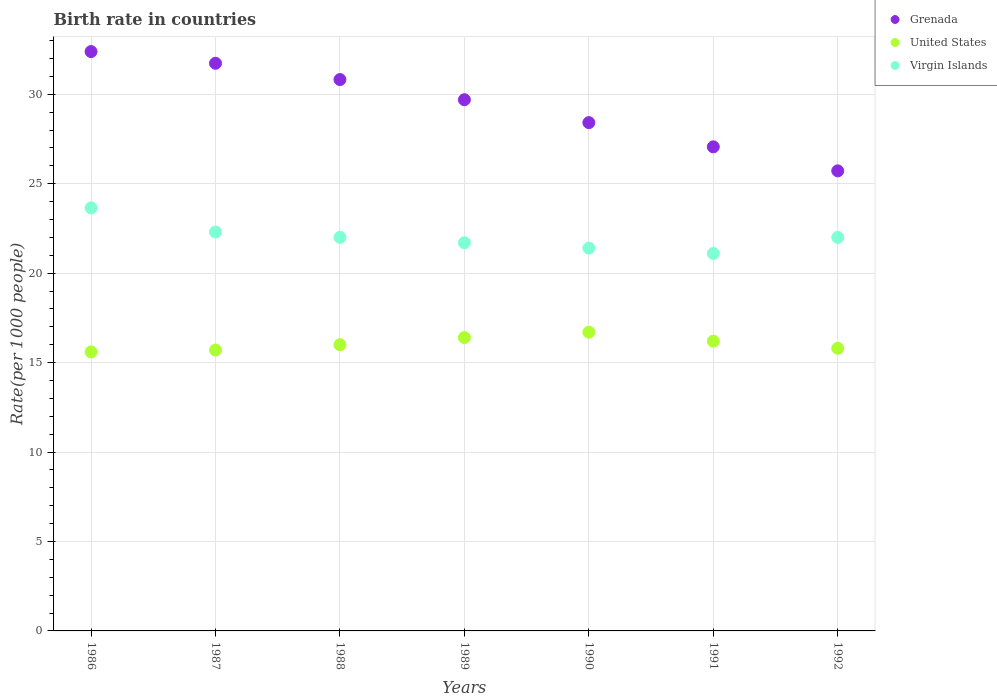Across all years, what is the maximum birth rate in Virgin Islands?
Keep it short and to the point. 23.65. Across all years, what is the minimum birth rate in Virgin Islands?
Your answer should be very brief. 21.1. In which year was the birth rate in United States maximum?
Your answer should be very brief. 1990. What is the total birth rate in Grenada in the graph?
Provide a short and direct response. 205.83. What is the difference between the birth rate in Grenada in 1988 and that in 1992?
Offer a terse response. 5.1. What is the difference between the birth rate in Virgin Islands in 1991 and the birth rate in United States in 1992?
Make the answer very short. 5.3. What is the average birth rate in Grenada per year?
Give a very brief answer. 29.4. In the year 1989, what is the difference between the birth rate in Virgin Islands and birth rate in Grenada?
Ensure brevity in your answer.  -8. What is the ratio of the birth rate in United States in 1987 to that in 1992?
Offer a terse response. 0.99. Is the birth rate in United States in 1989 less than that in 1990?
Make the answer very short. Yes. What is the difference between the highest and the second highest birth rate in United States?
Keep it short and to the point. 0.3. What is the difference between the highest and the lowest birth rate in Grenada?
Your answer should be compact. 6.67. In how many years, is the birth rate in United States greater than the average birth rate in United States taken over all years?
Ensure brevity in your answer.  3. Is it the case that in every year, the sum of the birth rate in United States and birth rate in Grenada  is greater than the birth rate in Virgin Islands?
Your answer should be very brief. Yes. Does the birth rate in Virgin Islands monotonically increase over the years?
Provide a short and direct response. No. Is the birth rate in United States strictly greater than the birth rate in Virgin Islands over the years?
Give a very brief answer. No. Is the birth rate in Grenada strictly less than the birth rate in United States over the years?
Make the answer very short. No. How many years are there in the graph?
Your answer should be compact. 7. What is the difference between two consecutive major ticks on the Y-axis?
Offer a very short reply. 5. Does the graph contain grids?
Make the answer very short. Yes. How are the legend labels stacked?
Your answer should be very brief. Vertical. What is the title of the graph?
Make the answer very short. Birth rate in countries. What is the label or title of the X-axis?
Offer a very short reply. Years. What is the label or title of the Y-axis?
Your answer should be compact. Rate(per 1000 people). What is the Rate(per 1000 people) of Grenada in 1986?
Ensure brevity in your answer.  32.39. What is the Rate(per 1000 people) in Virgin Islands in 1986?
Your answer should be very brief. 23.65. What is the Rate(per 1000 people) in Grenada in 1987?
Ensure brevity in your answer.  31.73. What is the Rate(per 1000 people) of United States in 1987?
Provide a succinct answer. 15.7. What is the Rate(per 1000 people) of Virgin Islands in 1987?
Provide a short and direct response. 22.3. What is the Rate(per 1000 people) of Grenada in 1988?
Give a very brief answer. 30.82. What is the Rate(per 1000 people) of United States in 1988?
Keep it short and to the point. 16. What is the Rate(per 1000 people) of Grenada in 1989?
Provide a succinct answer. 29.7. What is the Rate(per 1000 people) of Virgin Islands in 1989?
Your answer should be very brief. 21.7. What is the Rate(per 1000 people) of Grenada in 1990?
Provide a short and direct response. 28.41. What is the Rate(per 1000 people) in United States in 1990?
Your answer should be compact. 16.7. What is the Rate(per 1000 people) in Virgin Islands in 1990?
Offer a terse response. 21.4. What is the Rate(per 1000 people) of Grenada in 1991?
Ensure brevity in your answer.  27.06. What is the Rate(per 1000 people) in Virgin Islands in 1991?
Your answer should be very brief. 21.1. What is the Rate(per 1000 people) of Grenada in 1992?
Your answer should be compact. 25.72. What is the Rate(per 1000 people) of United States in 1992?
Ensure brevity in your answer.  15.8. What is the Rate(per 1000 people) in Virgin Islands in 1992?
Your response must be concise. 22. Across all years, what is the maximum Rate(per 1000 people) of Grenada?
Your answer should be very brief. 32.39. Across all years, what is the maximum Rate(per 1000 people) in United States?
Offer a terse response. 16.7. Across all years, what is the maximum Rate(per 1000 people) of Virgin Islands?
Your response must be concise. 23.65. Across all years, what is the minimum Rate(per 1000 people) in Grenada?
Offer a terse response. 25.72. Across all years, what is the minimum Rate(per 1000 people) of Virgin Islands?
Ensure brevity in your answer.  21.1. What is the total Rate(per 1000 people) of Grenada in the graph?
Keep it short and to the point. 205.83. What is the total Rate(per 1000 people) in United States in the graph?
Keep it short and to the point. 112.4. What is the total Rate(per 1000 people) in Virgin Islands in the graph?
Provide a succinct answer. 154.15. What is the difference between the Rate(per 1000 people) of Grenada in 1986 and that in 1987?
Provide a short and direct response. 0.65. What is the difference between the Rate(per 1000 people) of United States in 1986 and that in 1987?
Offer a very short reply. -0.1. What is the difference between the Rate(per 1000 people) in Virgin Islands in 1986 and that in 1987?
Make the answer very short. 1.35. What is the difference between the Rate(per 1000 people) of Grenada in 1986 and that in 1988?
Keep it short and to the point. 1.56. What is the difference between the Rate(per 1000 people) in United States in 1986 and that in 1988?
Your answer should be compact. -0.4. What is the difference between the Rate(per 1000 people) in Virgin Islands in 1986 and that in 1988?
Give a very brief answer. 1.65. What is the difference between the Rate(per 1000 people) in Grenada in 1986 and that in 1989?
Your response must be concise. 2.69. What is the difference between the Rate(per 1000 people) in United States in 1986 and that in 1989?
Offer a terse response. -0.8. What is the difference between the Rate(per 1000 people) of Virgin Islands in 1986 and that in 1989?
Keep it short and to the point. 1.95. What is the difference between the Rate(per 1000 people) of Grenada in 1986 and that in 1990?
Offer a terse response. 3.97. What is the difference between the Rate(per 1000 people) in Virgin Islands in 1986 and that in 1990?
Provide a short and direct response. 2.25. What is the difference between the Rate(per 1000 people) of Grenada in 1986 and that in 1991?
Your response must be concise. 5.33. What is the difference between the Rate(per 1000 people) of United States in 1986 and that in 1991?
Your answer should be very brief. -0.6. What is the difference between the Rate(per 1000 people) in Virgin Islands in 1986 and that in 1991?
Provide a succinct answer. 2.55. What is the difference between the Rate(per 1000 people) in Grenada in 1986 and that in 1992?
Give a very brief answer. 6.67. What is the difference between the Rate(per 1000 people) of United States in 1986 and that in 1992?
Provide a short and direct response. -0.2. What is the difference between the Rate(per 1000 people) of Virgin Islands in 1986 and that in 1992?
Make the answer very short. 1.65. What is the difference between the Rate(per 1000 people) in Grenada in 1987 and that in 1988?
Your answer should be compact. 0.91. What is the difference between the Rate(per 1000 people) in United States in 1987 and that in 1988?
Make the answer very short. -0.3. What is the difference between the Rate(per 1000 people) of Virgin Islands in 1987 and that in 1988?
Make the answer very short. 0.3. What is the difference between the Rate(per 1000 people) in Grenada in 1987 and that in 1989?
Make the answer very short. 2.04. What is the difference between the Rate(per 1000 people) of United States in 1987 and that in 1989?
Make the answer very short. -0.7. What is the difference between the Rate(per 1000 people) of Grenada in 1987 and that in 1990?
Your answer should be compact. 3.32. What is the difference between the Rate(per 1000 people) in United States in 1987 and that in 1990?
Offer a terse response. -1. What is the difference between the Rate(per 1000 people) in Grenada in 1987 and that in 1991?
Make the answer very short. 4.67. What is the difference between the Rate(per 1000 people) of Grenada in 1987 and that in 1992?
Your response must be concise. 6.01. What is the difference between the Rate(per 1000 people) of United States in 1987 and that in 1992?
Your answer should be compact. -0.1. What is the difference between the Rate(per 1000 people) in Grenada in 1988 and that in 1989?
Your answer should be compact. 1.13. What is the difference between the Rate(per 1000 people) in Grenada in 1988 and that in 1990?
Provide a succinct answer. 2.41. What is the difference between the Rate(per 1000 people) in United States in 1988 and that in 1990?
Provide a short and direct response. -0.7. What is the difference between the Rate(per 1000 people) in Grenada in 1988 and that in 1991?
Offer a very short reply. 3.76. What is the difference between the Rate(per 1000 people) in Grenada in 1988 and that in 1992?
Provide a short and direct response. 5.1. What is the difference between the Rate(per 1000 people) in Virgin Islands in 1988 and that in 1992?
Offer a very short reply. 0. What is the difference between the Rate(per 1000 people) in Grenada in 1989 and that in 1990?
Provide a succinct answer. 1.28. What is the difference between the Rate(per 1000 people) in Virgin Islands in 1989 and that in 1990?
Provide a short and direct response. 0.3. What is the difference between the Rate(per 1000 people) of Grenada in 1989 and that in 1991?
Give a very brief answer. 2.63. What is the difference between the Rate(per 1000 people) in United States in 1989 and that in 1991?
Ensure brevity in your answer.  0.2. What is the difference between the Rate(per 1000 people) in Virgin Islands in 1989 and that in 1991?
Your answer should be very brief. 0.6. What is the difference between the Rate(per 1000 people) in Grenada in 1989 and that in 1992?
Offer a terse response. 3.98. What is the difference between the Rate(per 1000 people) in Grenada in 1990 and that in 1991?
Make the answer very short. 1.35. What is the difference between the Rate(per 1000 people) of United States in 1990 and that in 1991?
Your response must be concise. 0.5. What is the difference between the Rate(per 1000 people) of Virgin Islands in 1990 and that in 1991?
Make the answer very short. 0.3. What is the difference between the Rate(per 1000 people) in Grenada in 1990 and that in 1992?
Provide a short and direct response. 2.7. What is the difference between the Rate(per 1000 people) of Grenada in 1991 and that in 1992?
Keep it short and to the point. 1.34. What is the difference between the Rate(per 1000 people) of United States in 1991 and that in 1992?
Your answer should be very brief. 0.4. What is the difference between the Rate(per 1000 people) in Virgin Islands in 1991 and that in 1992?
Make the answer very short. -0.9. What is the difference between the Rate(per 1000 people) of Grenada in 1986 and the Rate(per 1000 people) of United States in 1987?
Provide a short and direct response. 16.69. What is the difference between the Rate(per 1000 people) in Grenada in 1986 and the Rate(per 1000 people) in Virgin Islands in 1987?
Your answer should be compact. 10.09. What is the difference between the Rate(per 1000 people) of Grenada in 1986 and the Rate(per 1000 people) of United States in 1988?
Offer a terse response. 16.39. What is the difference between the Rate(per 1000 people) in Grenada in 1986 and the Rate(per 1000 people) in Virgin Islands in 1988?
Your answer should be very brief. 10.39. What is the difference between the Rate(per 1000 people) of Grenada in 1986 and the Rate(per 1000 people) of United States in 1989?
Offer a terse response. 15.99. What is the difference between the Rate(per 1000 people) in Grenada in 1986 and the Rate(per 1000 people) in Virgin Islands in 1989?
Keep it short and to the point. 10.69. What is the difference between the Rate(per 1000 people) in Grenada in 1986 and the Rate(per 1000 people) in United States in 1990?
Offer a very short reply. 15.69. What is the difference between the Rate(per 1000 people) in Grenada in 1986 and the Rate(per 1000 people) in Virgin Islands in 1990?
Offer a terse response. 10.99. What is the difference between the Rate(per 1000 people) of United States in 1986 and the Rate(per 1000 people) of Virgin Islands in 1990?
Provide a succinct answer. -5.8. What is the difference between the Rate(per 1000 people) in Grenada in 1986 and the Rate(per 1000 people) in United States in 1991?
Your answer should be compact. 16.19. What is the difference between the Rate(per 1000 people) of Grenada in 1986 and the Rate(per 1000 people) of Virgin Islands in 1991?
Your response must be concise. 11.29. What is the difference between the Rate(per 1000 people) of Grenada in 1986 and the Rate(per 1000 people) of United States in 1992?
Provide a succinct answer. 16.59. What is the difference between the Rate(per 1000 people) in Grenada in 1986 and the Rate(per 1000 people) in Virgin Islands in 1992?
Give a very brief answer. 10.39. What is the difference between the Rate(per 1000 people) of Grenada in 1987 and the Rate(per 1000 people) of United States in 1988?
Make the answer very short. 15.73. What is the difference between the Rate(per 1000 people) of Grenada in 1987 and the Rate(per 1000 people) of Virgin Islands in 1988?
Make the answer very short. 9.73. What is the difference between the Rate(per 1000 people) in Grenada in 1987 and the Rate(per 1000 people) in United States in 1989?
Offer a terse response. 15.33. What is the difference between the Rate(per 1000 people) of Grenada in 1987 and the Rate(per 1000 people) of Virgin Islands in 1989?
Offer a very short reply. 10.03. What is the difference between the Rate(per 1000 people) in Grenada in 1987 and the Rate(per 1000 people) in United States in 1990?
Your answer should be compact. 15.03. What is the difference between the Rate(per 1000 people) in Grenada in 1987 and the Rate(per 1000 people) in Virgin Islands in 1990?
Offer a terse response. 10.33. What is the difference between the Rate(per 1000 people) of Grenada in 1987 and the Rate(per 1000 people) of United States in 1991?
Provide a succinct answer. 15.53. What is the difference between the Rate(per 1000 people) in Grenada in 1987 and the Rate(per 1000 people) in Virgin Islands in 1991?
Make the answer very short. 10.63. What is the difference between the Rate(per 1000 people) in United States in 1987 and the Rate(per 1000 people) in Virgin Islands in 1991?
Your answer should be compact. -5.4. What is the difference between the Rate(per 1000 people) of Grenada in 1987 and the Rate(per 1000 people) of United States in 1992?
Ensure brevity in your answer.  15.93. What is the difference between the Rate(per 1000 people) of Grenada in 1987 and the Rate(per 1000 people) of Virgin Islands in 1992?
Give a very brief answer. 9.73. What is the difference between the Rate(per 1000 people) in United States in 1987 and the Rate(per 1000 people) in Virgin Islands in 1992?
Offer a very short reply. -6.3. What is the difference between the Rate(per 1000 people) of Grenada in 1988 and the Rate(per 1000 people) of United States in 1989?
Ensure brevity in your answer.  14.42. What is the difference between the Rate(per 1000 people) in Grenada in 1988 and the Rate(per 1000 people) in Virgin Islands in 1989?
Keep it short and to the point. 9.12. What is the difference between the Rate(per 1000 people) in Grenada in 1988 and the Rate(per 1000 people) in United States in 1990?
Your answer should be compact. 14.12. What is the difference between the Rate(per 1000 people) of Grenada in 1988 and the Rate(per 1000 people) of Virgin Islands in 1990?
Provide a succinct answer. 9.42. What is the difference between the Rate(per 1000 people) in United States in 1988 and the Rate(per 1000 people) in Virgin Islands in 1990?
Provide a short and direct response. -5.4. What is the difference between the Rate(per 1000 people) of Grenada in 1988 and the Rate(per 1000 people) of United States in 1991?
Offer a very short reply. 14.62. What is the difference between the Rate(per 1000 people) in Grenada in 1988 and the Rate(per 1000 people) in Virgin Islands in 1991?
Your answer should be very brief. 9.72. What is the difference between the Rate(per 1000 people) of Grenada in 1988 and the Rate(per 1000 people) of United States in 1992?
Keep it short and to the point. 15.02. What is the difference between the Rate(per 1000 people) in Grenada in 1988 and the Rate(per 1000 people) in Virgin Islands in 1992?
Your answer should be compact. 8.82. What is the difference between the Rate(per 1000 people) in Grenada in 1989 and the Rate(per 1000 people) in United States in 1990?
Your response must be concise. 12.99. What is the difference between the Rate(per 1000 people) in Grenada in 1989 and the Rate(per 1000 people) in Virgin Islands in 1990?
Ensure brevity in your answer.  8.29. What is the difference between the Rate(per 1000 people) in United States in 1989 and the Rate(per 1000 people) in Virgin Islands in 1990?
Offer a terse response. -5. What is the difference between the Rate(per 1000 people) in Grenada in 1989 and the Rate(per 1000 people) in United States in 1991?
Offer a terse response. 13.49. What is the difference between the Rate(per 1000 people) in Grenada in 1989 and the Rate(per 1000 people) in Virgin Islands in 1991?
Offer a very short reply. 8.6. What is the difference between the Rate(per 1000 people) in Grenada in 1989 and the Rate(per 1000 people) in United States in 1992?
Your answer should be compact. 13.89. What is the difference between the Rate(per 1000 people) of Grenada in 1989 and the Rate(per 1000 people) of Virgin Islands in 1992?
Your answer should be very brief. 7.7. What is the difference between the Rate(per 1000 people) in Grenada in 1990 and the Rate(per 1000 people) in United States in 1991?
Give a very brief answer. 12.21. What is the difference between the Rate(per 1000 people) in Grenada in 1990 and the Rate(per 1000 people) in Virgin Islands in 1991?
Give a very brief answer. 7.32. What is the difference between the Rate(per 1000 people) in Grenada in 1990 and the Rate(per 1000 people) in United States in 1992?
Your answer should be compact. 12.62. What is the difference between the Rate(per 1000 people) of Grenada in 1990 and the Rate(per 1000 people) of Virgin Islands in 1992?
Ensure brevity in your answer.  6.42. What is the difference between the Rate(per 1000 people) of Grenada in 1991 and the Rate(per 1000 people) of United States in 1992?
Your response must be concise. 11.26. What is the difference between the Rate(per 1000 people) of Grenada in 1991 and the Rate(per 1000 people) of Virgin Islands in 1992?
Your answer should be compact. 5.06. What is the average Rate(per 1000 people) in Grenada per year?
Offer a terse response. 29.4. What is the average Rate(per 1000 people) of United States per year?
Keep it short and to the point. 16.06. What is the average Rate(per 1000 people) of Virgin Islands per year?
Your answer should be compact. 22.02. In the year 1986, what is the difference between the Rate(per 1000 people) in Grenada and Rate(per 1000 people) in United States?
Make the answer very short. 16.79. In the year 1986, what is the difference between the Rate(per 1000 people) in Grenada and Rate(per 1000 people) in Virgin Islands?
Give a very brief answer. 8.74. In the year 1986, what is the difference between the Rate(per 1000 people) in United States and Rate(per 1000 people) in Virgin Islands?
Make the answer very short. -8.05. In the year 1987, what is the difference between the Rate(per 1000 people) in Grenada and Rate(per 1000 people) in United States?
Offer a terse response. 16.03. In the year 1987, what is the difference between the Rate(per 1000 people) in Grenada and Rate(per 1000 people) in Virgin Islands?
Ensure brevity in your answer.  9.43. In the year 1987, what is the difference between the Rate(per 1000 people) of United States and Rate(per 1000 people) of Virgin Islands?
Your answer should be very brief. -6.6. In the year 1988, what is the difference between the Rate(per 1000 people) in Grenada and Rate(per 1000 people) in United States?
Your response must be concise. 14.82. In the year 1988, what is the difference between the Rate(per 1000 people) of Grenada and Rate(per 1000 people) of Virgin Islands?
Provide a succinct answer. 8.82. In the year 1989, what is the difference between the Rate(per 1000 people) in Grenada and Rate(per 1000 people) in United States?
Give a very brief answer. 13.29. In the year 1989, what is the difference between the Rate(per 1000 people) of Grenada and Rate(per 1000 people) of Virgin Islands?
Provide a short and direct response. 8. In the year 1990, what is the difference between the Rate(per 1000 people) in Grenada and Rate(per 1000 people) in United States?
Offer a terse response. 11.71. In the year 1990, what is the difference between the Rate(per 1000 people) in Grenada and Rate(per 1000 people) in Virgin Islands?
Offer a very short reply. 7.01. In the year 1991, what is the difference between the Rate(per 1000 people) of Grenada and Rate(per 1000 people) of United States?
Your answer should be very brief. 10.86. In the year 1991, what is the difference between the Rate(per 1000 people) in Grenada and Rate(per 1000 people) in Virgin Islands?
Your answer should be very brief. 5.96. In the year 1991, what is the difference between the Rate(per 1000 people) in United States and Rate(per 1000 people) in Virgin Islands?
Keep it short and to the point. -4.9. In the year 1992, what is the difference between the Rate(per 1000 people) of Grenada and Rate(per 1000 people) of United States?
Give a very brief answer. 9.92. In the year 1992, what is the difference between the Rate(per 1000 people) in Grenada and Rate(per 1000 people) in Virgin Islands?
Make the answer very short. 3.72. In the year 1992, what is the difference between the Rate(per 1000 people) of United States and Rate(per 1000 people) of Virgin Islands?
Your answer should be very brief. -6.2. What is the ratio of the Rate(per 1000 people) in Grenada in 1986 to that in 1987?
Make the answer very short. 1.02. What is the ratio of the Rate(per 1000 people) of Virgin Islands in 1986 to that in 1987?
Make the answer very short. 1.06. What is the ratio of the Rate(per 1000 people) of Grenada in 1986 to that in 1988?
Your answer should be very brief. 1.05. What is the ratio of the Rate(per 1000 people) in Virgin Islands in 1986 to that in 1988?
Your answer should be compact. 1.07. What is the ratio of the Rate(per 1000 people) of Grenada in 1986 to that in 1989?
Your answer should be compact. 1.09. What is the ratio of the Rate(per 1000 people) of United States in 1986 to that in 1989?
Offer a terse response. 0.95. What is the ratio of the Rate(per 1000 people) in Virgin Islands in 1986 to that in 1989?
Keep it short and to the point. 1.09. What is the ratio of the Rate(per 1000 people) in Grenada in 1986 to that in 1990?
Provide a succinct answer. 1.14. What is the ratio of the Rate(per 1000 people) of United States in 1986 to that in 1990?
Give a very brief answer. 0.93. What is the ratio of the Rate(per 1000 people) of Virgin Islands in 1986 to that in 1990?
Make the answer very short. 1.11. What is the ratio of the Rate(per 1000 people) in Grenada in 1986 to that in 1991?
Make the answer very short. 1.2. What is the ratio of the Rate(per 1000 people) in United States in 1986 to that in 1991?
Your answer should be compact. 0.96. What is the ratio of the Rate(per 1000 people) of Virgin Islands in 1986 to that in 1991?
Provide a short and direct response. 1.12. What is the ratio of the Rate(per 1000 people) in Grenada in 1986 to that in 1992?
Give a very brief answer. 1.26. What is the ratio of the Rate(per 1000 people) of United States in 1986 to that in 1992?
Provide a succinct answer. 0.99. What is the ratio of the Rate(per 1000 people) of Virgin Islands in 1986 to that in 1992?
Your answer should be very brief. 1.07. What is the ratio of the Rate(per 1000 people) in Grenada in 1987 to that in 1988?
Your answer should be very brief. 1.03. What is the ratio of the Rate(per 1000 people) in United States in 1987 to that in 1988?
Your response must be concise. 0.98. What is the ratio of the Rate(per 1000 people) of Virgin Islands in 1987 to that in 1988?
Your response must be concise. 1.01. What is the ratio of the Rate(per 1000 people) in Grenada in 1987 to that in 1989?
Provide a succinct answer. 1.07. What is the ratio of the Rate(per 1000 people) of United States in 1987 to that in 1989?
Give a very brief answer. 0.96. What is the ratio of the Rate(per 1000 people) of Virgin Islands in 1987 to that in 1989?
Provide a succinct answer. 1.03. What is the ratio of the Rate(per 1000 people) of Grenada in 1987 to that in 1990?
Keep it short and to the point. 1.12. What is the ratio of the Rate(per 1000 people) of United States in 1987 to that in 1990?
Offer a very short reply. 0.94. What is the ratio of the Rate(per 1000 people) in Virgin Islands in 1987 to that in 1990?
Offer a terse response. 1.04. What is the ratio of the Rate(per 1000 people) in Grenada in 1987 to that in 1991?
Give a very brief answer. 1.17. What is the ratio of the Rate(per 1000 people) in United States in 1987 to that in 1991?
Ensure brevity in your answer.  0.97. What is the ratio of the Rate(per 1000 people) in Virgin Islands in 1987 to that in 1991?
Your response must be concise. 1.06. What is the ratio of the Rate(per 1000 people) in Grenada in 1987 to that in 1992?
Your response must be concise. 1.23. What is the ratio of the Rate(per 1000 people) of Virgin Islands in 1987 to that in 1992?
Your response must be concise. 1.01. What is the ratio of the Rate(per 1000 people) in Grenada in 1988 to that in 1989?
Offer a terse response. 1.04. What is the ratio of the Rate(per 1000 people) in United States in 1988 to that in 1989?
Offer a very short reply. 0.98. What is the ratio of the Rate(per 1000 people) of Virgin Islands in 1988 to that in 1989?
Offer a terse response. 1.01. What is the ratio of the Rate(per 1000 people) in Grenada in 1988 to that in 1990?
Provide a short and direct response. 1.08. What is the ratio of the Rate(per 1000 people) in United States in 1988 to that in 1990?
Ensure brevity in your answer.  0.96. What is the ratio of the Rate(per 1000 people) in Virgin Islands in 1988 to that in 1990?
Make the answer very short. 1.03. What is the ratio of the Rate(per 1000 people) in Grenada in 1988 to that in 1991?
Keep it short and to the point. 1.14. What is the ratio of the Rate(per 1000 people) in Virgin Islands in 1988 to that in 1991?
Provide a short and direct response. 1.04. What is the ratio of the Rate(per 1000 people) of Grenada in 1988 to that in 1992?
Make the answer very short. 1.2. What is the ratio of the Rate(per 1000 people) in United States in 1988 to that in 1992?
Your answer should be very brief. 1.01. What is the ratio of the Rate(per 1000 people) in Grenada in 1989 to that in 1990?
Provide a succinct answer. 1.04. What is the ratio of the Rate(per 1000 people) of Grenada in 1989 to that in 1991?
Your answer should be compact. 1.1. What is the ratio of the Rate(per 1000 people) in United States in 1989 to that in 1991?
Ensure brevity in your answer.  1.01. What is the ratio of the Rate(per 1000 people) in Virgin Islands in 1989 to that in 1991?
Provide a succinct answer. 1.03. What is the ratio of the Rate(per 1000 people) of Grenada in 1989 to that in 1992?
Your answer should be very brief. 1.15. What is the ratio of the Rate(per 1000 people) in United States in 1989 to that in 1992?
Your answer should be very brief. 1.04. What is the ratio of the Rate(per 1000 people) of Virgin Islands in 1989 to that in 1992?
Ensure brevity in your answer.  0.99. What is the ratio of the Rate(per 1000 people) of Grenada in 1990 to that in 1991?
Provide a short and direct response. 1.05. What is the ratio of the Rate(per 1000 people) of United States in 1990 to that in 1991?
Your response must be concise. 1.03. What is the ratio of the Rate(per 1000 people) in Virgin Islands in 1990 to that in 1991?
Your answer should be compact. 1.01. What is the ratio of the Rate(per 1000 people) of Grenada in 1990 to that in 1992?
Give a very brief answer. 1.1. What is the ratio of the Rate(per 1000 people) of United States in 1990 to that in 1992?
Your response must be concise. 1.06. What is the ratio of the Rate(per 1000 people) of Virgin Islands in 1990 to that in 1992?
Give a very brief answer. 0.97. What is the ratio of the Rate(per 1000 people) of Grenada in 1991 to that in 1992?
Your answer should be very brief. 1.05. What is the ratio of the Rate(per 1000 people) in United States in 1991 to that in 1992?
Keep it short and to the point. 1.03. What is the ratio of the Rate(per 1000 people) of Virgin Islands in 1991 to that in 1992?
Give a very brief answer. 0.96. What is the difference between the highest and the second highest Rate(per 1000 people) of Grenada?
Your answer should be very brief. 0.65. What is the difference between the highest and the second highest Rate(per 1000 people) in United States?
Ensure brevity in your answer.  0.3. What is the difference between the highest and the second highest Rate(per 1000 people) in Virgin Islands?
Make the answer very short. 1.35. What is the difference between the highest and the lowest Rate(per 1000 people) in Grenada?
Provide a succinct answer. 6.67. What is the difference between the highest and the lowest Rate(per 1000 people) in United States?
Ensure brevity in your answer.  1.1. What is the difference between the highest and the lowest Rate(per 1000 people) of Virgin Islands?
Make the answer very short. 2.55. 